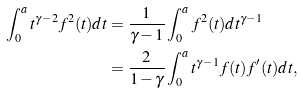<formula> <loc_0><loc_0><loc_500><loc_500>\int _ { 0 } ^ { a } t ^ { \gamma - 2 } f ^ { 2 } ( t ) d t & = \frac { 1 } { \gamma - 1 } \int _ { 0 } ^ { a } f ^ { 2 } ( t ) d t ^ { \gamma - 1 } \\ & = \frac { 2 } { 1 - \gamma } \int _ { 0 } ^ { a } t ^ { \gamma - 1 } f ( t ) f ^ { \prime } ( t ) d t ,</formula> 